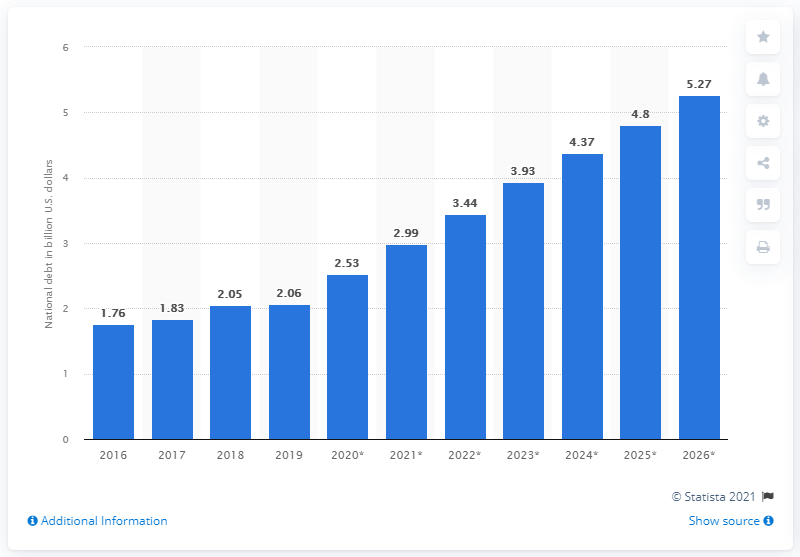Mention a couple of crucial points in this snapshot. In 2019, the national debt of Guyana was approximately 2.06 trillion dollars. 